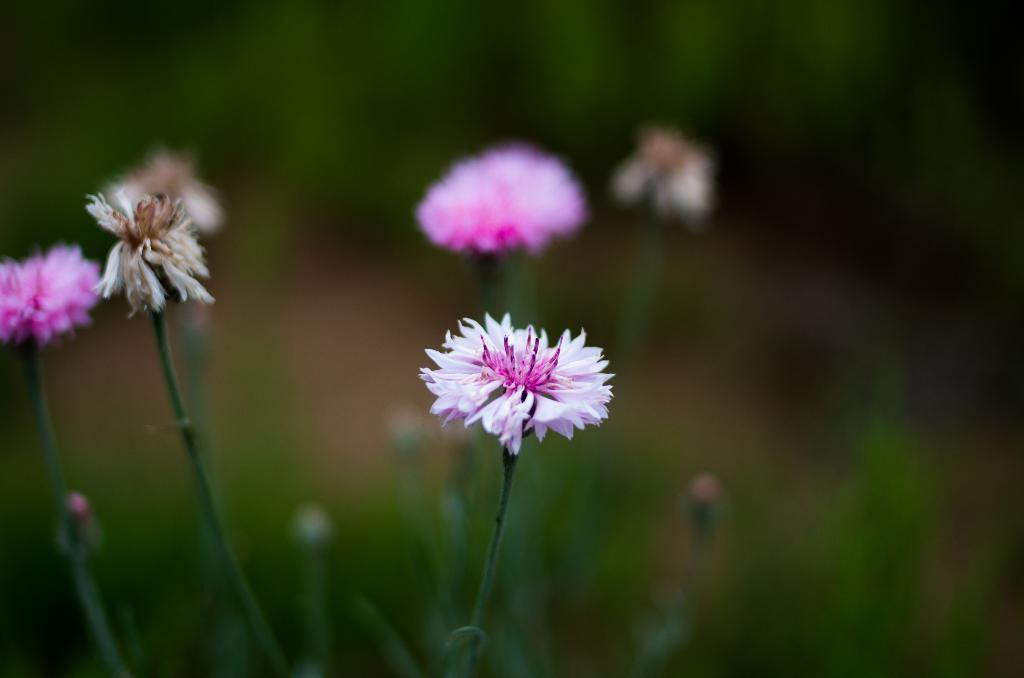What type of living organisms are present in the image? There are flowers in the image. Where are the flowers located? The flowers are on a plant. What colors can be seen in the flowers? The flowers are in pink and white colors. Can you describe the background of the image? The background of the image is blurred. How does the quince contribute to the image? There is no quince present in the image. What is the level of noise in the image? The image does not convey any information about the level of noise, as it is a still image. 